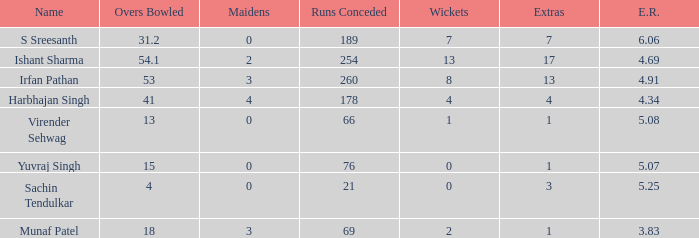Identify the designation for when 3 S Sreesanth. 